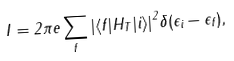Convert formula to latex. <formula><loc_0><loc_0><loc_500><loc_500>I = 2 \pi e \sum _ { f } { | \langle f | H _ { T } | i \rangle | } ^ { 2 } \delta ( \epsilon _ { i } - \epsilon _ { f } ) ,</formula> 